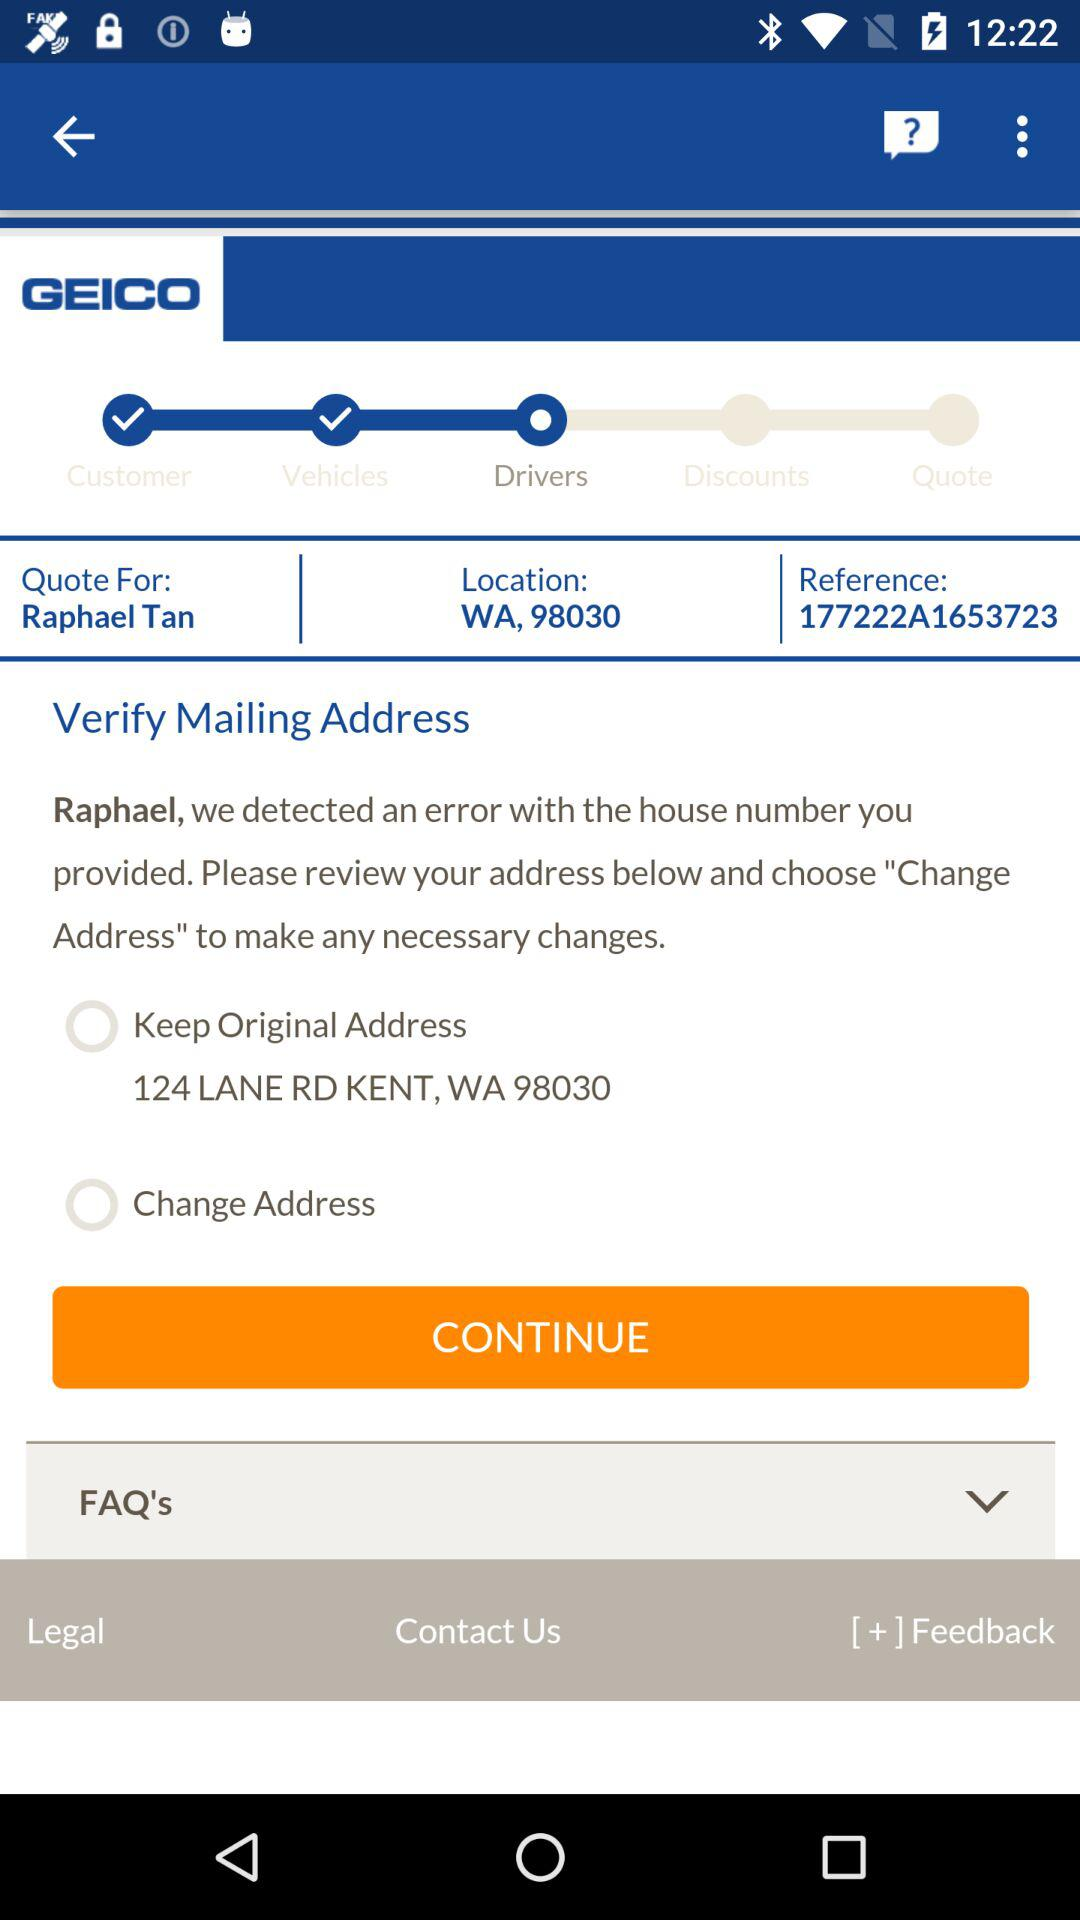What is the original address? The original address is 124 LANE RD KENT, WA 98030. 